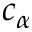Convert formula to latex. <formula><loc_0><loc_0><loc_500><loc_500>c _ { \alpha }</formula> 